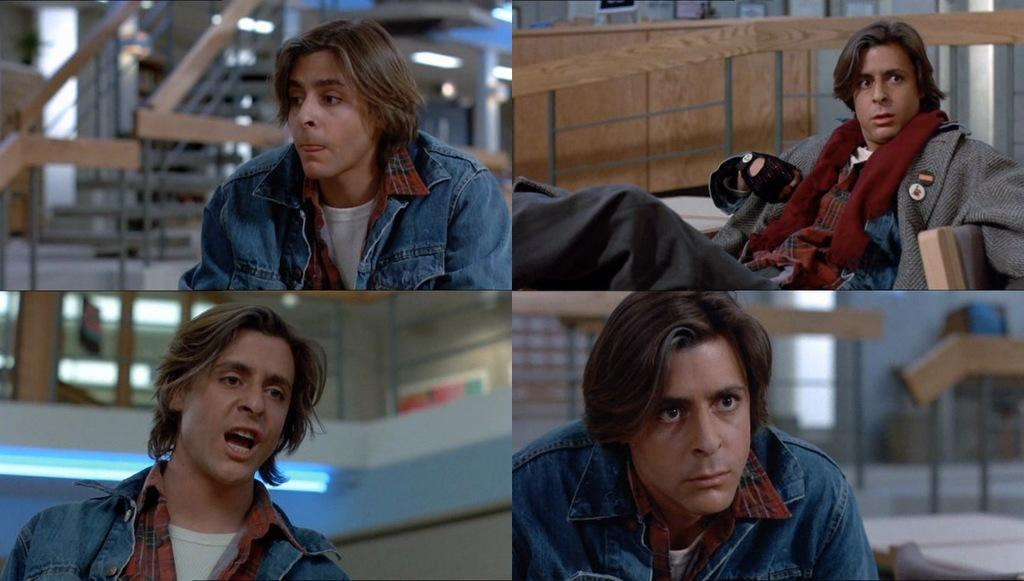What type of artwork is the image? The image is a collage. Can you describe the main subject in the image? There is a man sitting in the image. What can be seen in the background of the image? There are stairs, lights, and other objects visible in the background of the image. Can you tell me how many baseballs are being held by the goat in the image? There is no goat or baseball present in the image. What type of prison can be seen in the background of the image? There is no prison visible in the image; it features a collage with a man sitting and objects in the background. 